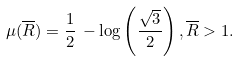<formula> <loc_0><loc_0><loc_500><loc_500>\mu ( \overline { R } ) = \frac { 1 } { 2 } \, - \log \left ( \frac { \sqrt { 3 } } { 2 } \right ) , \overline { R } > 1 .</formula> 